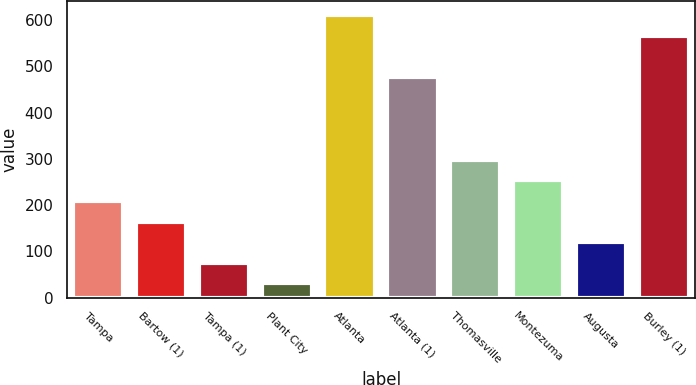<chart> <loc_0><loc_0><loc_500><loc_500><bar_chart><fcel>Tampa<fcel>Bartow (1)<fcel>Tampa (1)<fcel>Plant City<fcel>Atlanta<fcel>Atlanta (1)<fcel>Thomasville<fcel>Montezuma<fcel>Augusta<fcel>Burley (1)<nl><fcel>209.16<fcel>164.57<fcel>75.39<fcel>30.8<fcel>610.47<fcel>476.7<fcel>298.34<fcel>253.75<fcel>119.98<fcel>565.88<nl></chart> 